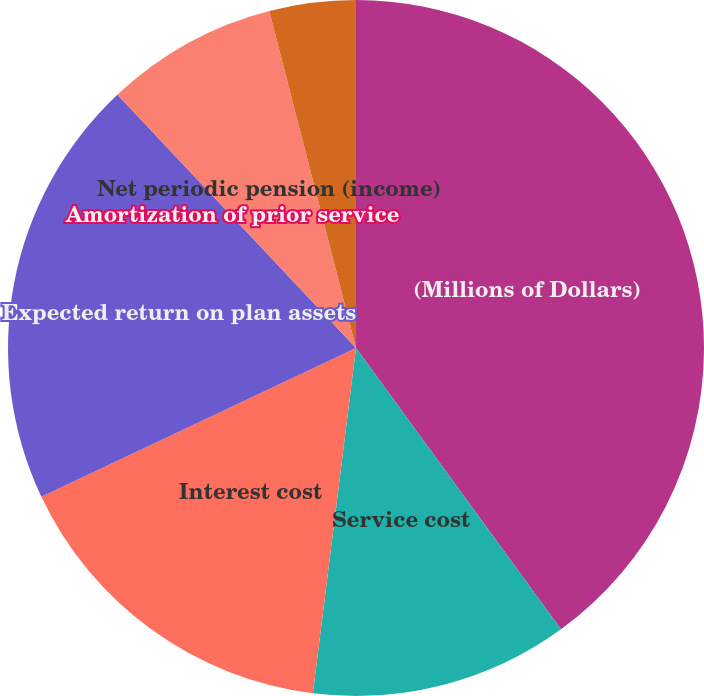<chart> <loc_0><loc_0><loc_500><loc_500><pie_chart><fcel>(Millions of Dollars)<fcel>Service cost<fcel>Interest cost<fcel>Expected return on plan assets<fcel>Amortization of prior service<fcel>Net periodic pension (income)<fcel>(Decrease) Increase in minimum<nl><fcel>39.98%<fcel>12.0%<fcel>16.0%<fcel>20.0%<fcel>0.01%<fcel>8.01%<fcel>4.01%<nl></chart> 